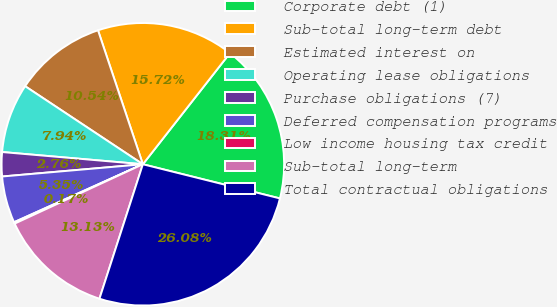<chart> <loc_0><loc_0><loc_500><loc_500><pie_chart><fcel>Corporate debt (1)<fcel>Sub-total long-term debt<fcel>Estimated interest on<fcel>Operating lease obligations<fcel>Purchase obligations (7)<fcel>Deferred compensation programs<fcel>Low income housing tax credit<fcel>Sub-total long-term<fcel>Total contractual obligations<nl><fcel>18.31%<fcel>15.72%<fcel>10.54%<fcel>7.94%<fcel>2.76%<fcel>5.35%<fcel>0.17%<fcel>13.13%<fcel>26.08%<nl></chart> 